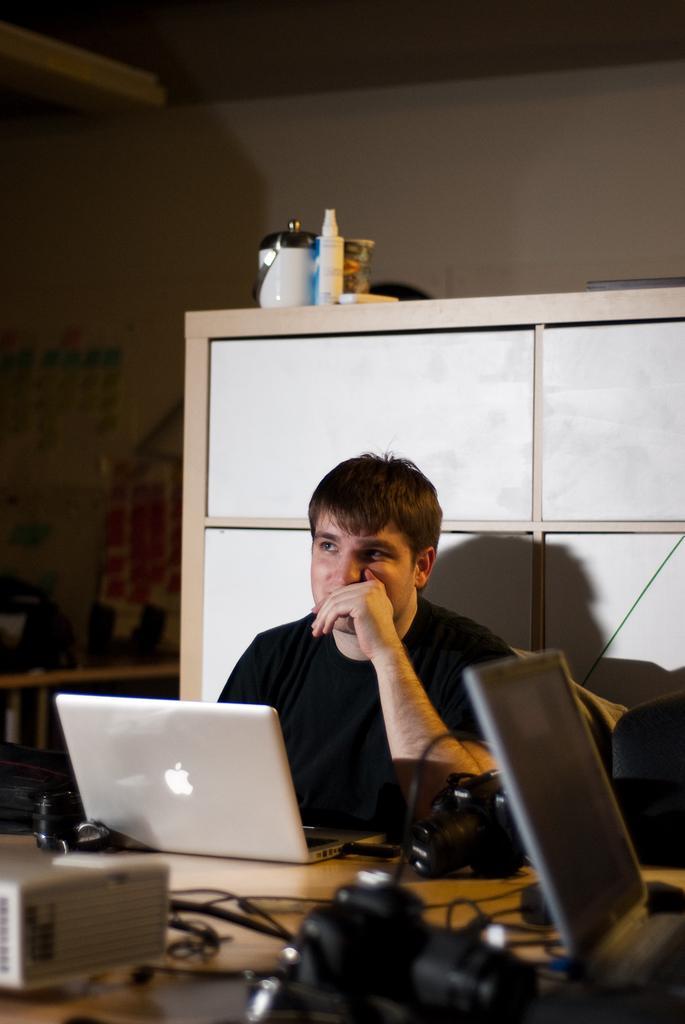How would you summarize this image in a sentence or two? In this image there is a man wearing a black t shirt sitting besides a table. On the table there are laptops, wire and cameras. In the background there is a cupboard, wall and a table. On the table there is a jar, a bottle and a remote etc. 